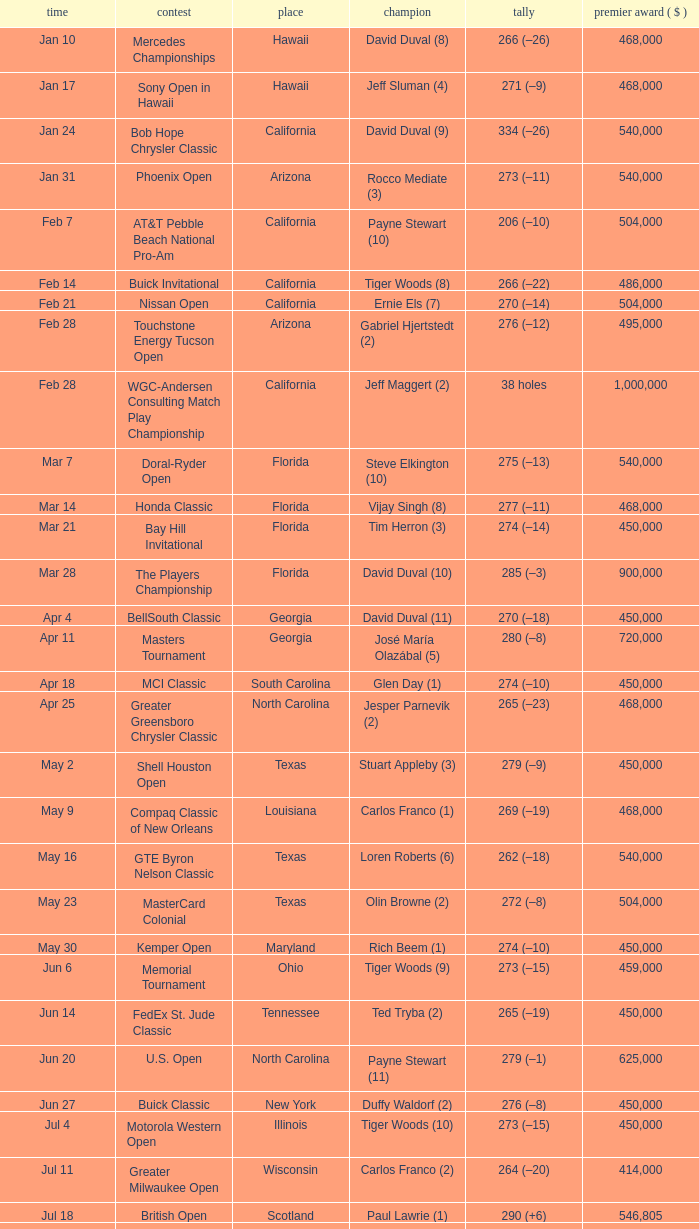Who is the winner of the tournament in Georgia on Oct 3? David Toms (3). 